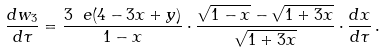Convert formula to latex. <formula><loc_0><loc_0><loc_500><loc_500>\frac { d w _ { 3 } } { d \tau } = \frac { 3 \ e ( 4 - 3 x + y ) } { 1 - x } \cdot \frac { \sqrt { 1 - x } - \sqrt { 1 + 3 x } } { \sqrt { 1 + 3 x } } \cdot \frac { d x } { d \tau } \, .</formula> 